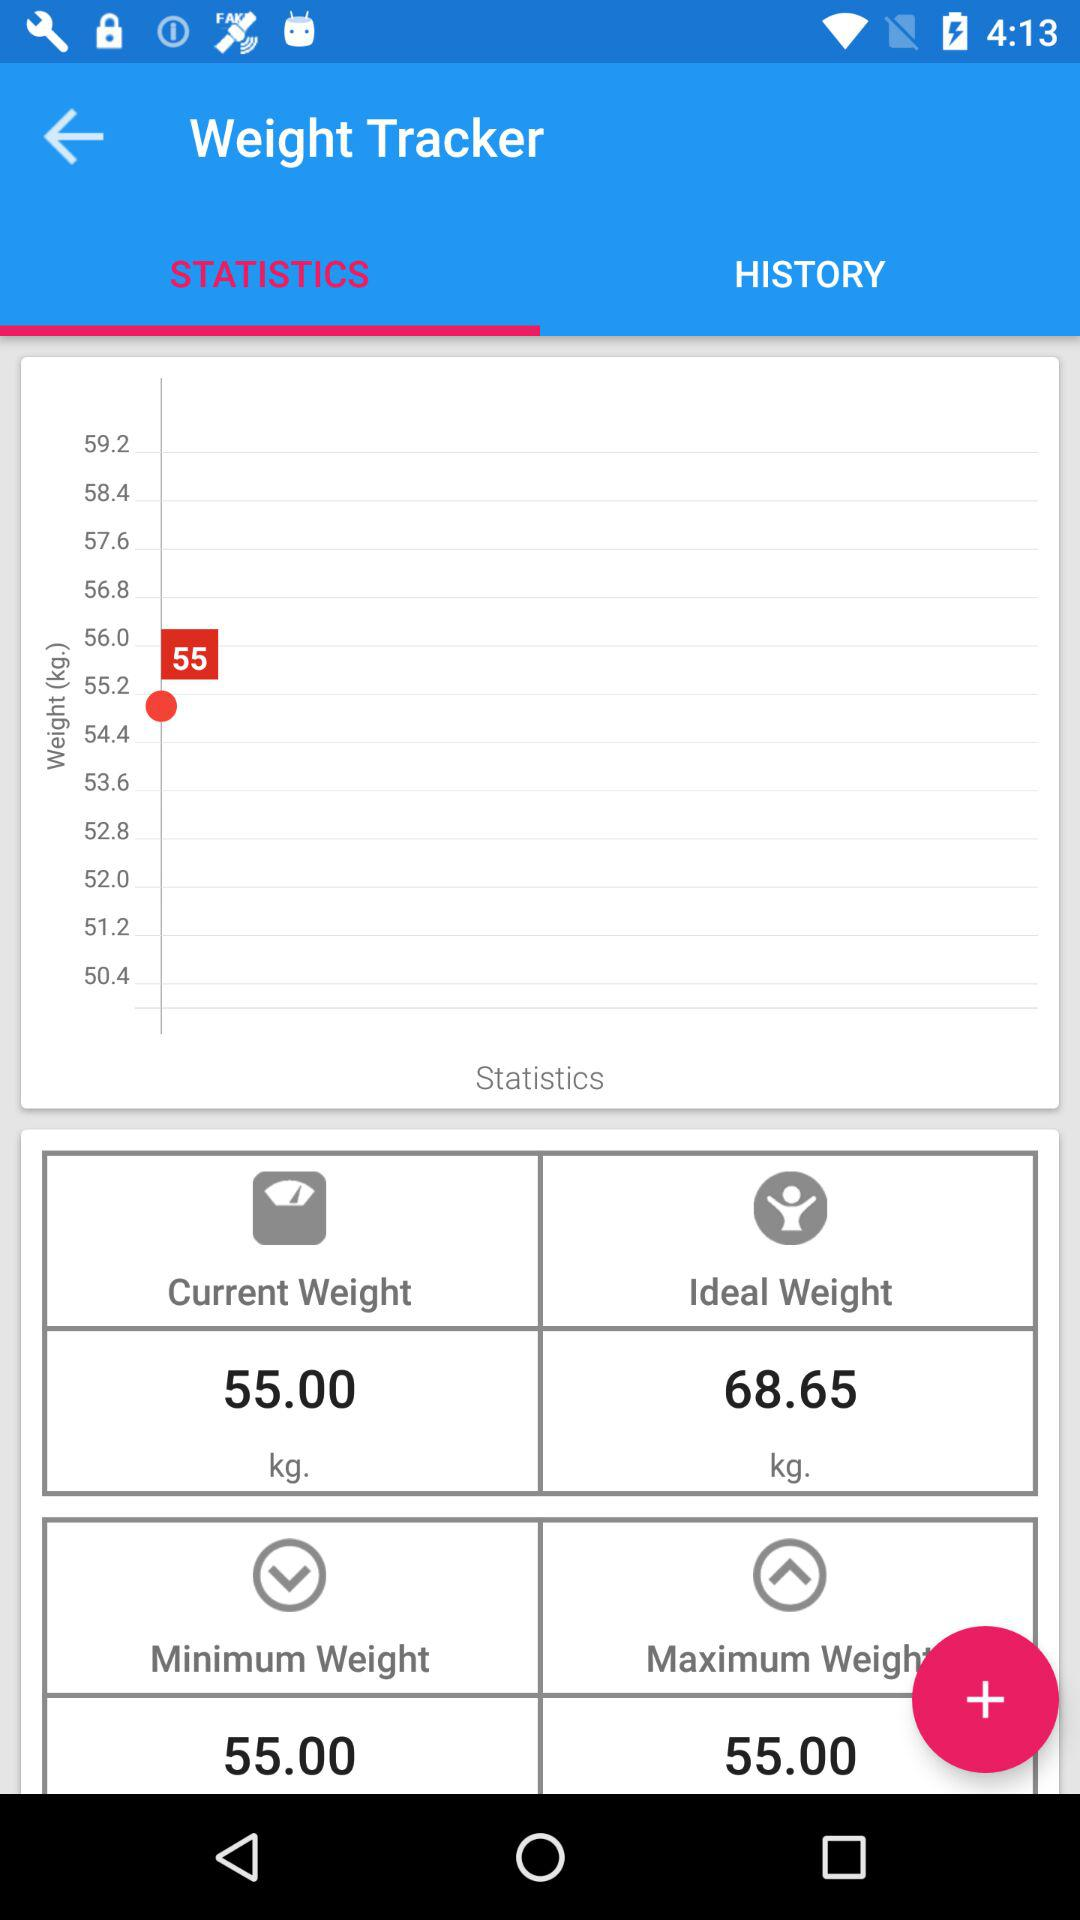How much is the ideal weight? The ideal weight is 68.65 kg. 